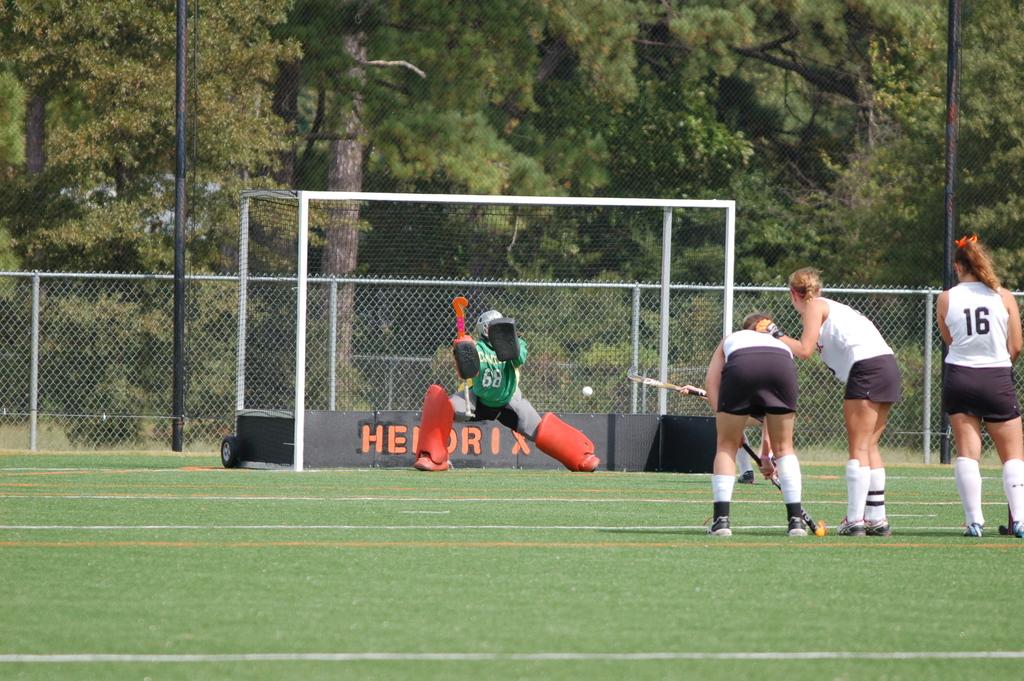What is the number of the player on the far right?
Offer a terse response. 16. 